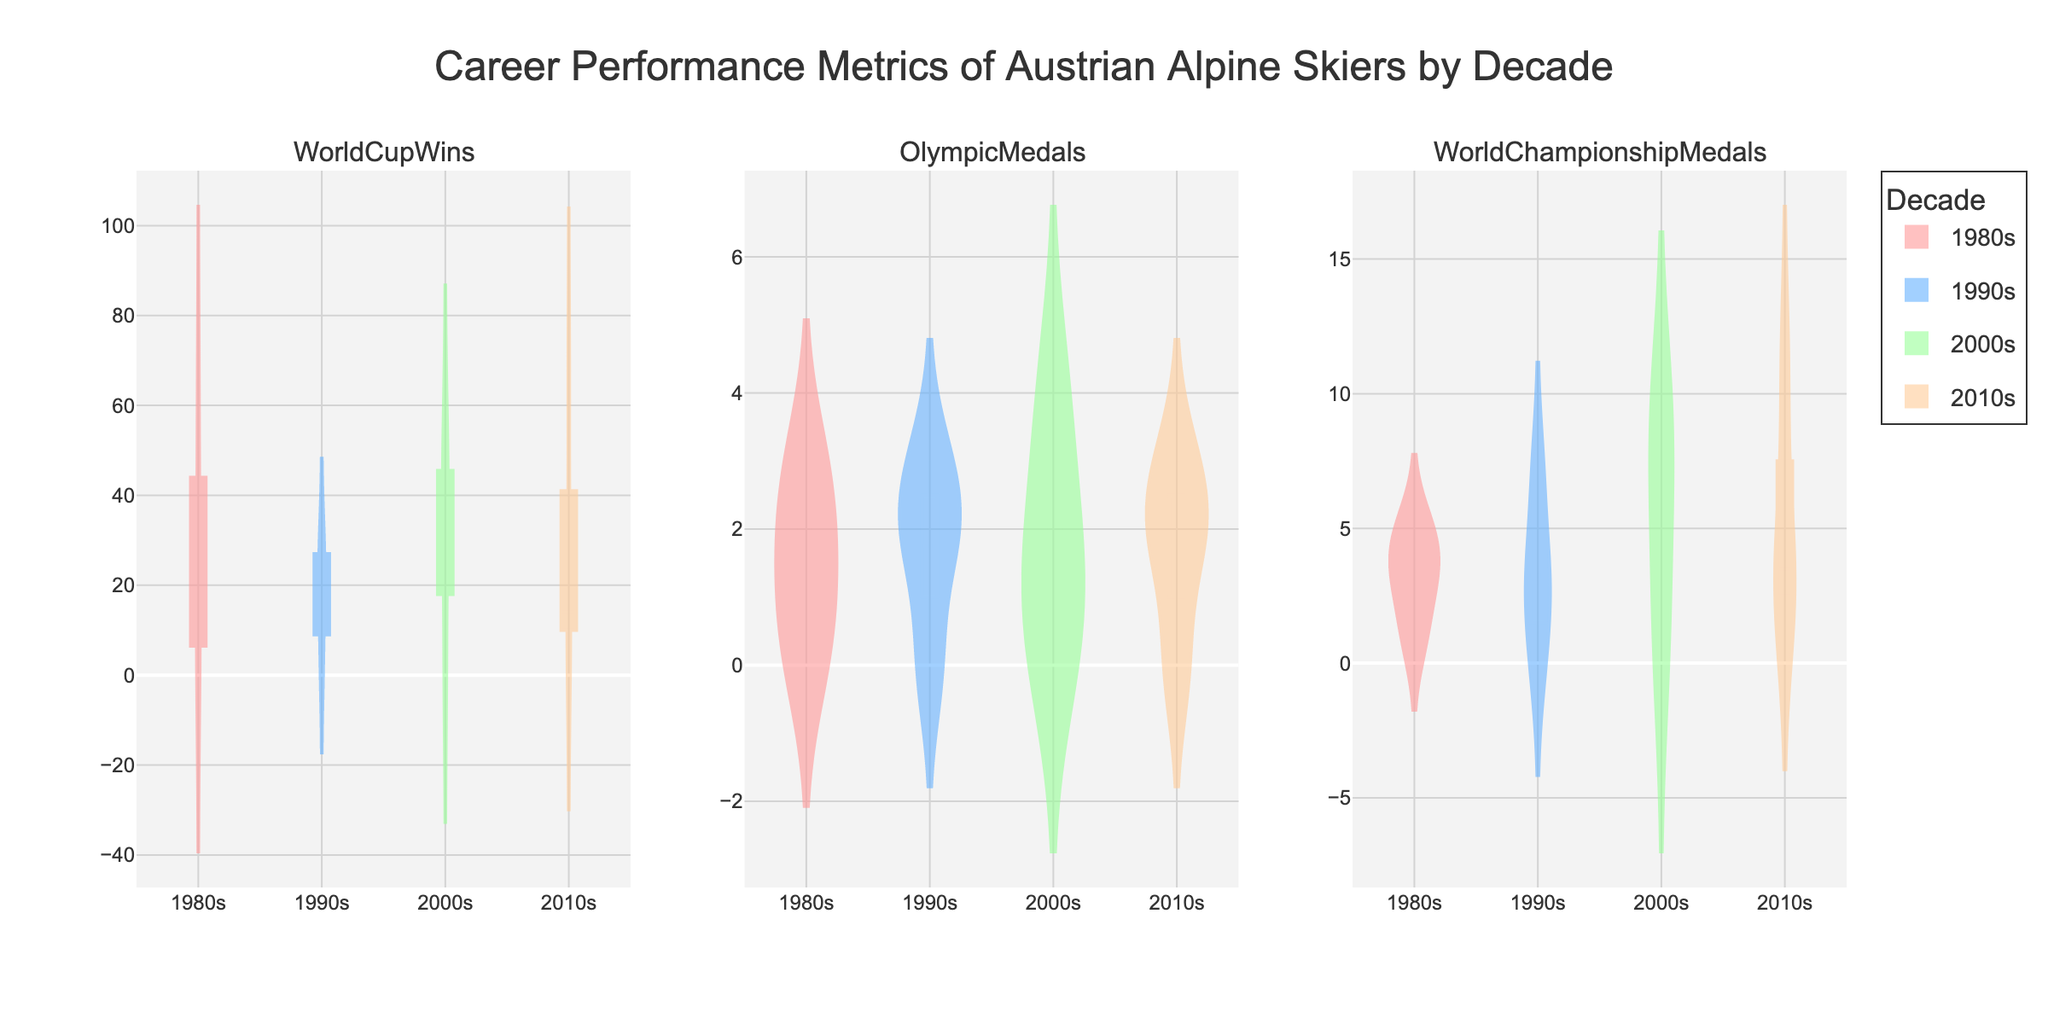What's the title of the figure? The title of a figure is usually located at the top and provides an overview of what the figure represents. In this case, the title is "Career Performance Metrics of Austrian Alpine Skiers by Decade".
Answer: Career Performance Metrics of Austrian Alpine Skiers by Decade How many subplots are there in the figure? By observing the figure, you can see that there are three distinct plots side by side. These subplots correspond to the three different metrics being displayed.
Answer: Three What are the metrics shown in the subplots? The subplot titles typically indicate the metrics they represent. By looking at the subplot titles, one can see the metrics are "WorldCupWins", "OlympicMedals", and "WorldChampionshipMedals".
Answer: WorldCupWins, OlympicMedals, WorldChampionshipMedals Which decade shows the highest density of World Cup wins? To answer this, observe the violin plots for the "WorldCupWins" subplot. The decade with the highest density will show the largest concentration of values around a certain point. The 2010s decade stands out with many high values.
Answer: 2010s What is the most common number of Olympic medals for skiers in the 2000s? Look at the "OlympicMedals" subplot and identify which number appears most frequently for the 2000s decade. It seems that 2 Olympic medals are the most common.
Answer: 2 Which decade has the lowest median value for World Championship medals? To find which decade has the lowest median value, observe the horizontal line representing the median in the "WorldChampionshipMedals" subplot. The 1980s decade appears to have the lowest median.
Answer: 1980s Compare the range of World Cup wins between the 2000s and 1990s. Which one has a wider range? By examining the spread of values (from the lowest to the highest) in the "WorldCupWins" subplot for both decades, you can see that the 2000s show a wider range compared to the 1990s.
Answer: 2000s For the 1990s, how do the mean values of World Cup wins and Olympic medals compare? Mean values are indicated by a horizontal line within the violin plot. For the 1990s, compare the mean lines in both "WorldCupWins" and "OlympicMedals" subplots. The mean World Cup wins appear higher than the mean Olympic medals.
Answer: Mean World Cup wins are higher What can be said about Manuela Ruef's performance in the 2000s based on the figure? Since Manuela Ruef's metrics are all zero, observe the corresponding location in each subplot for the 2000s. It shows that at least one skier has zero in all categories, which matches Manuela Ruef's performance.
Answer: Zero in all categories Which decade lacks any skiers with Olympic medals? By analyzing the "OlympicMedals" subplot, notice if any decade has no violin plot sections above zero. The 1980s decade lacks Olympic medals.
Answer: 1980s 